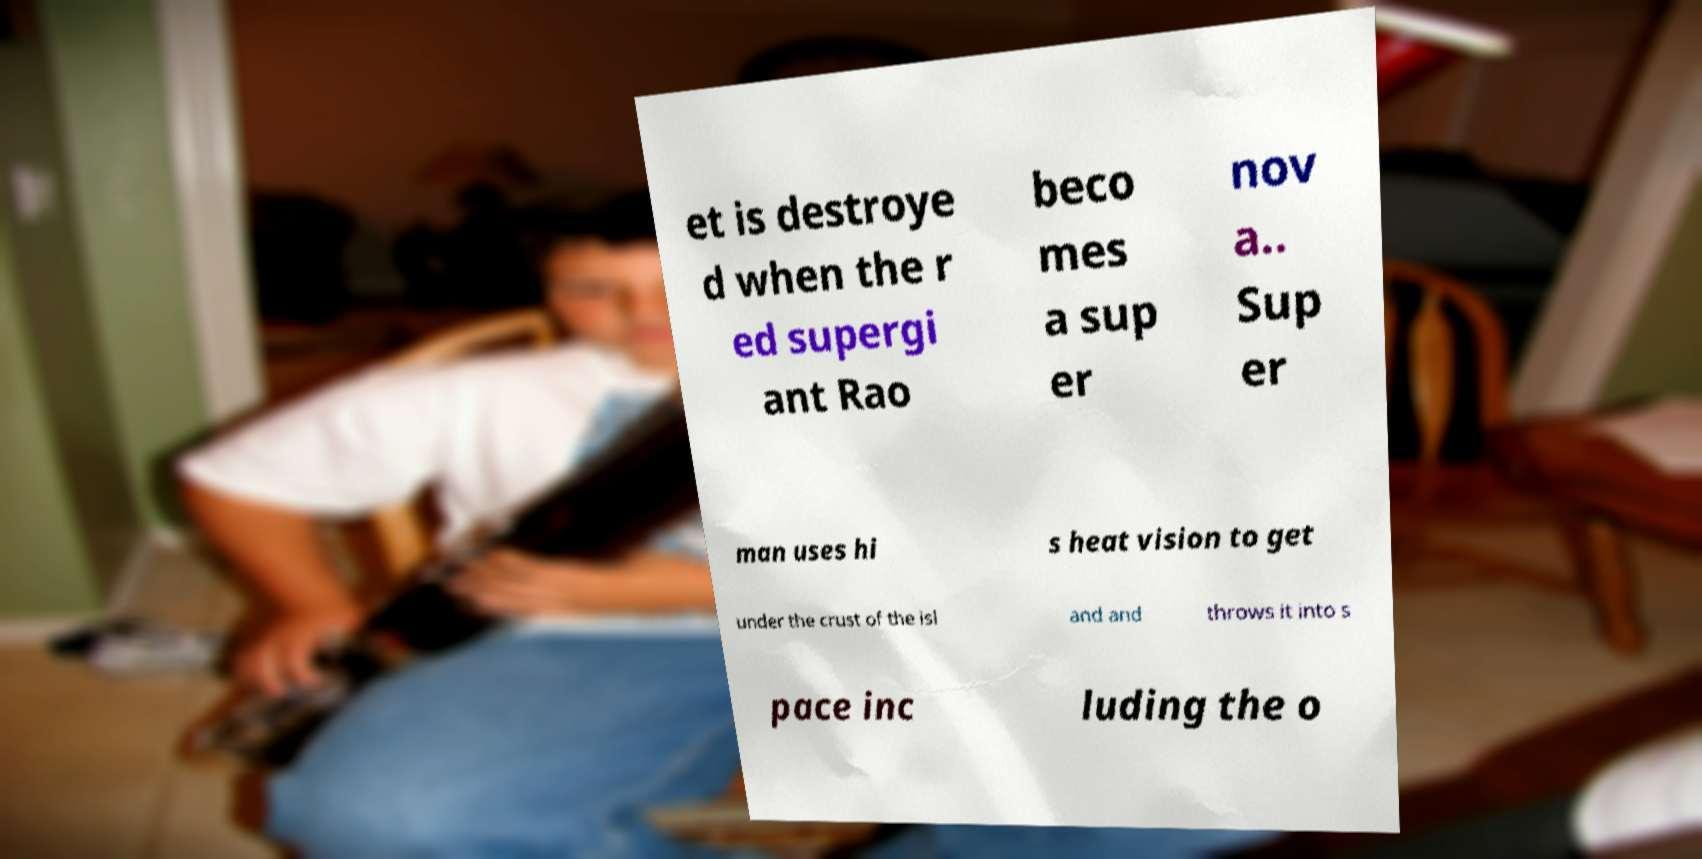Please identify and transcribe the text found in this image. et is destroye d when the r ed supergi ant Rao beco mes a sup er nov a.. Sup er man uses hi s heat vision to get under the crust of the isl and and throws it into s pace inc luding the o 